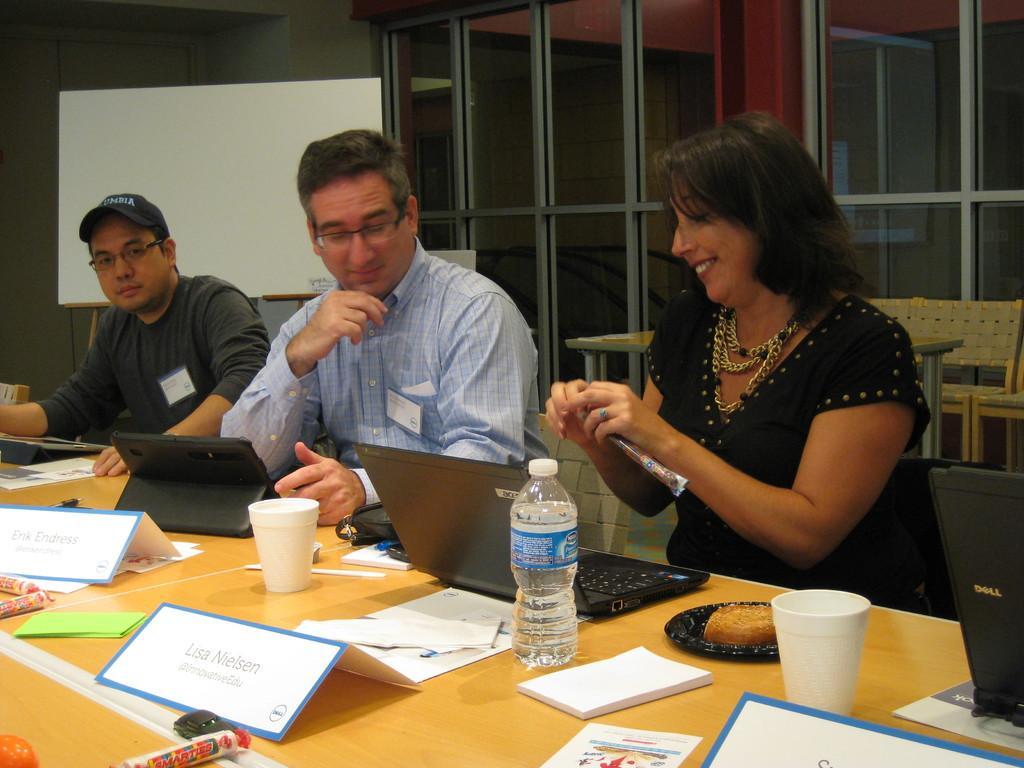Please provide a concise description of this image. In this picture, there are three people sitting beside the table. On the table, there are papers, books, laptops, devices etc are placed. Towards the right, there is a woman wearing black dress. Towards the left, there are two men. One of the man is wearing t shirt and another man is wearing shirt. Behind, them there is a whiteboard. In the background, there is a glass wall. 